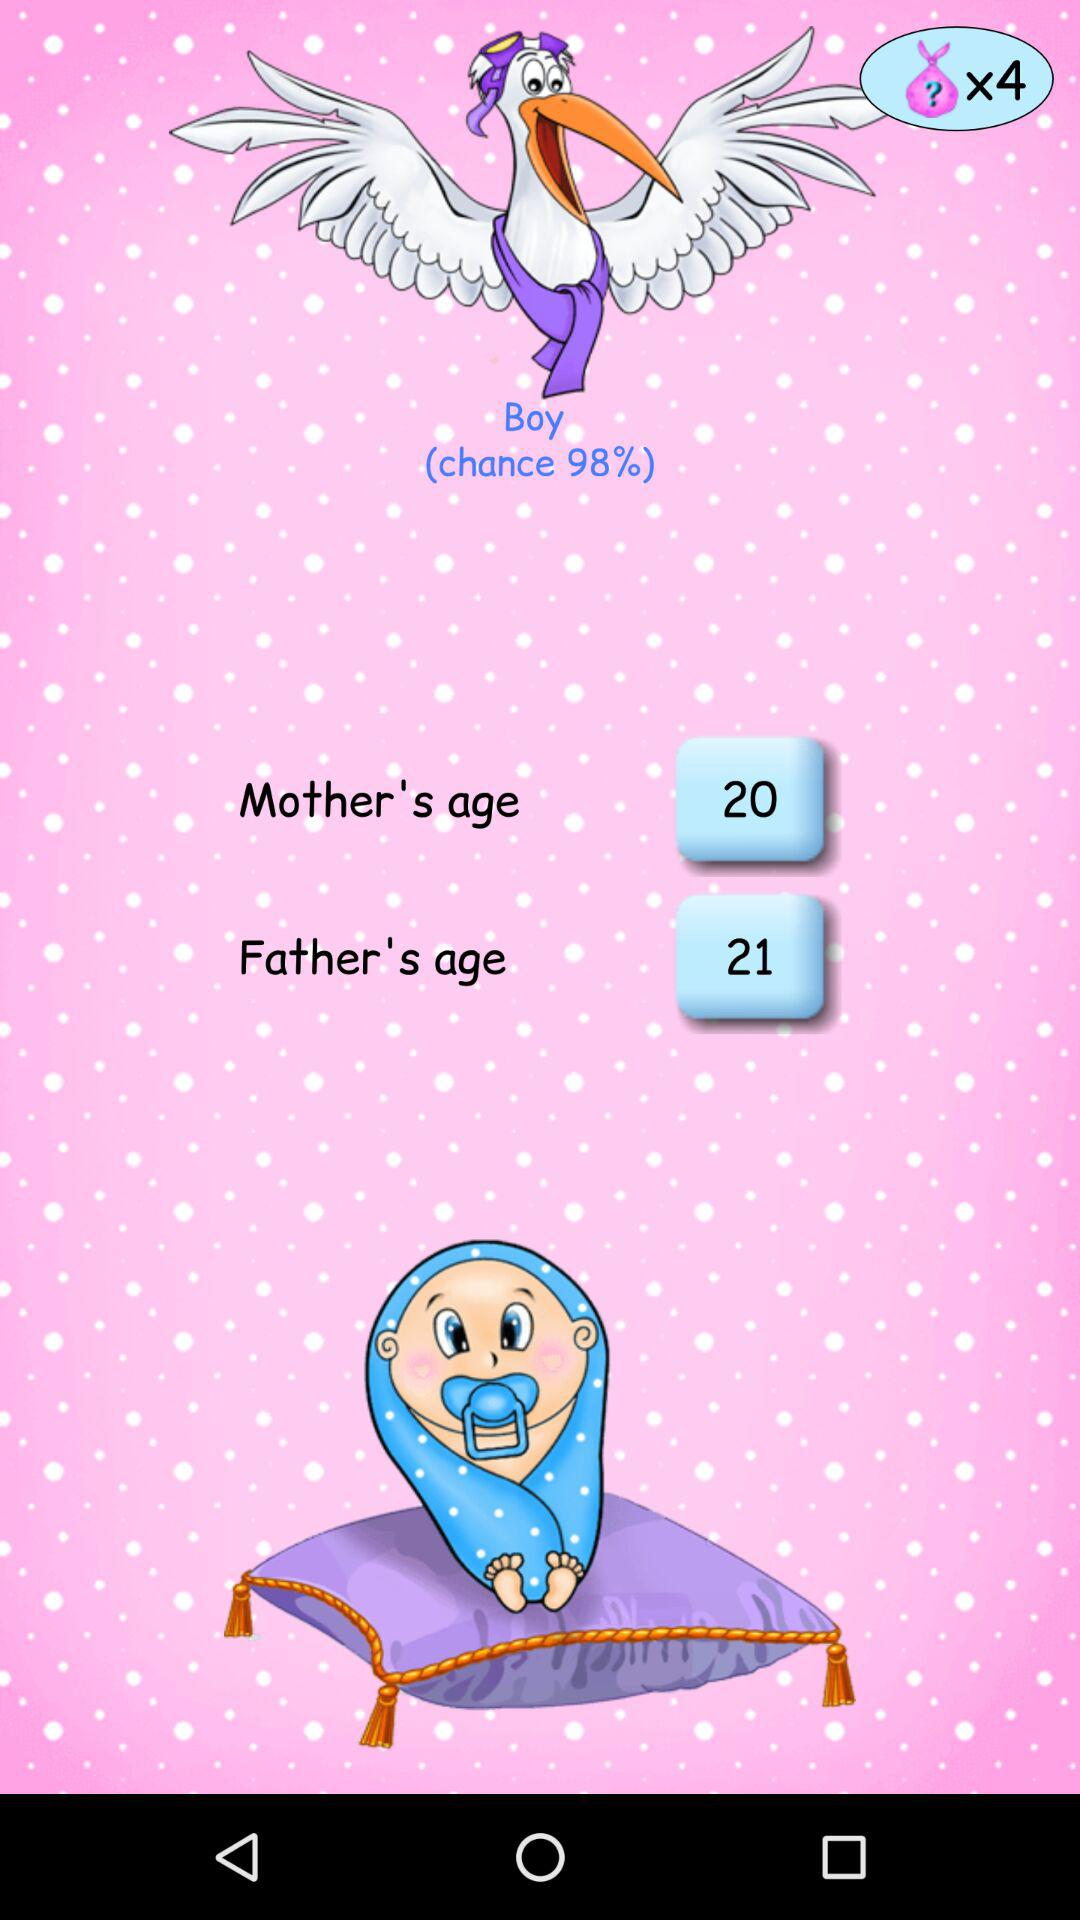What are the chances of having a boy? There are 98% chances of having a boy. 